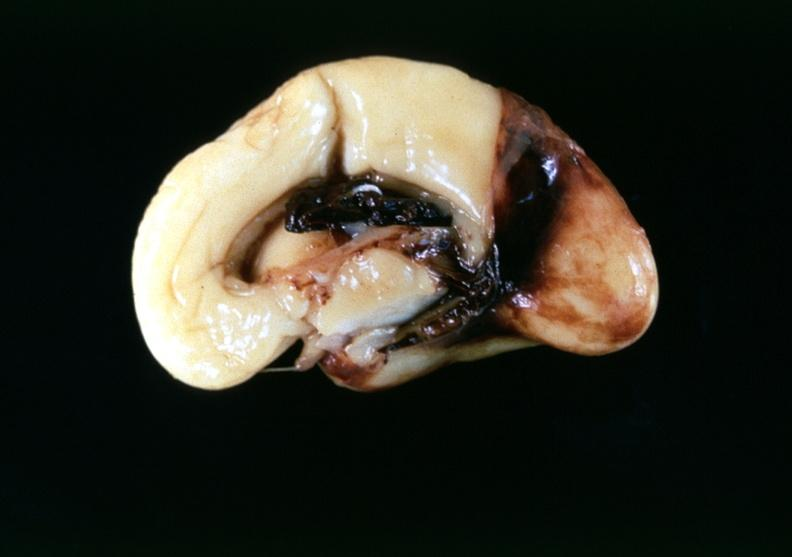what is present?
Answer the question using a single word or phrase. Nervous 